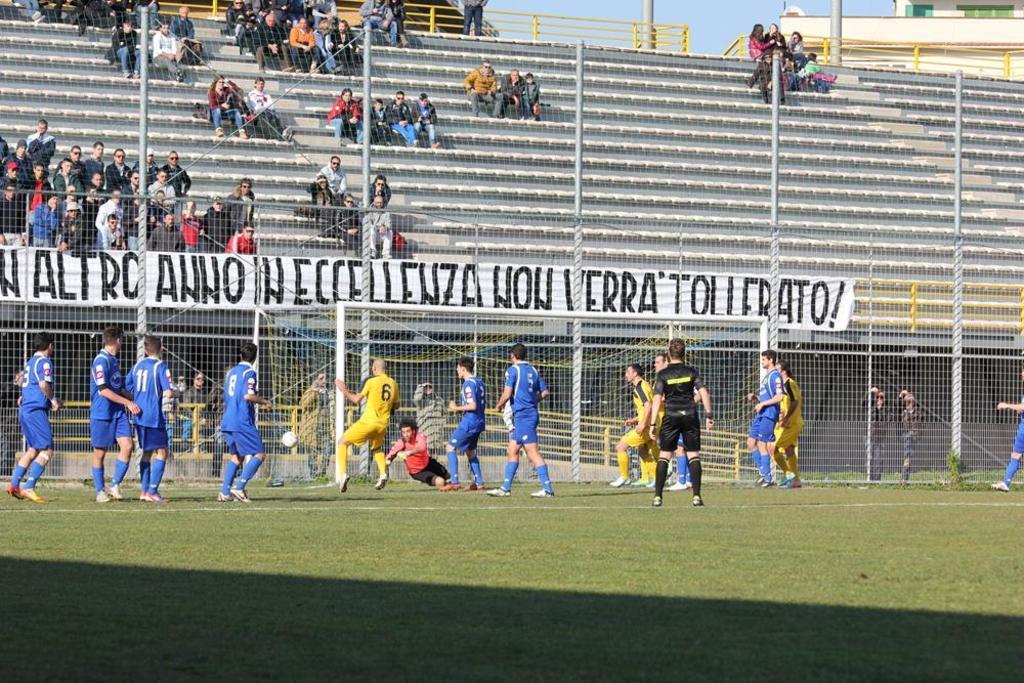Can you describe this image briefly? In this image I can see few players wearing different color dresses. I can see a netball,net fencing and a white banner. I can see a group of people sitting on the stairs. 